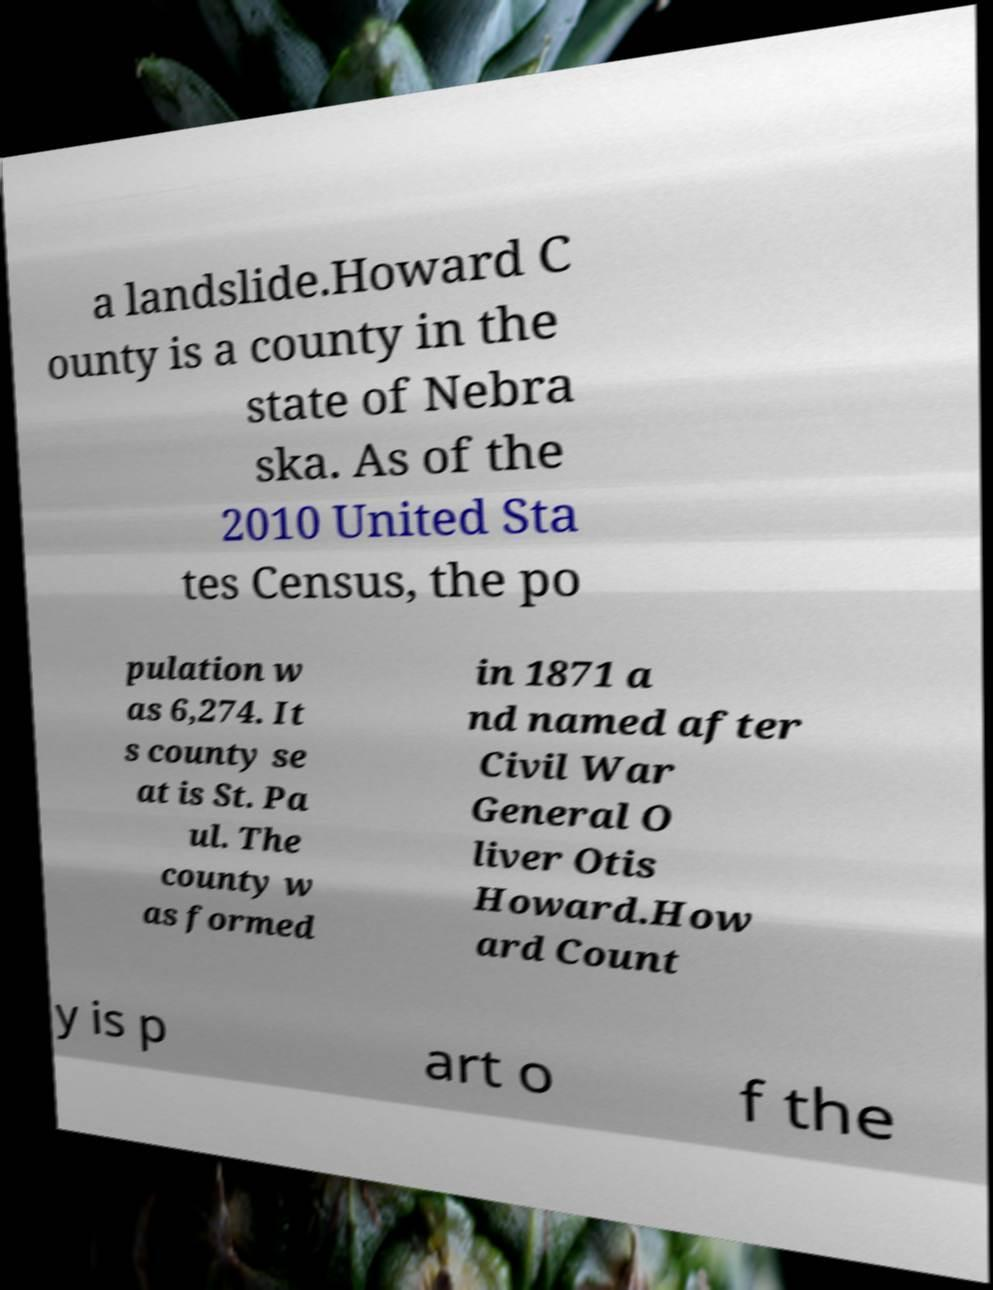Can you accurately transcribe the text from the provided image for me? a landslide.Howard C ounty is a county in the state of Nebra ska. As of the 2010 United Sta tes Census, the po pulation w as 6,274. It s county se at is St. Pa ul. The county w as formed in 1871 a nd named after Civil War General O liver Otis Howard.How ard Count y is p art o f the 